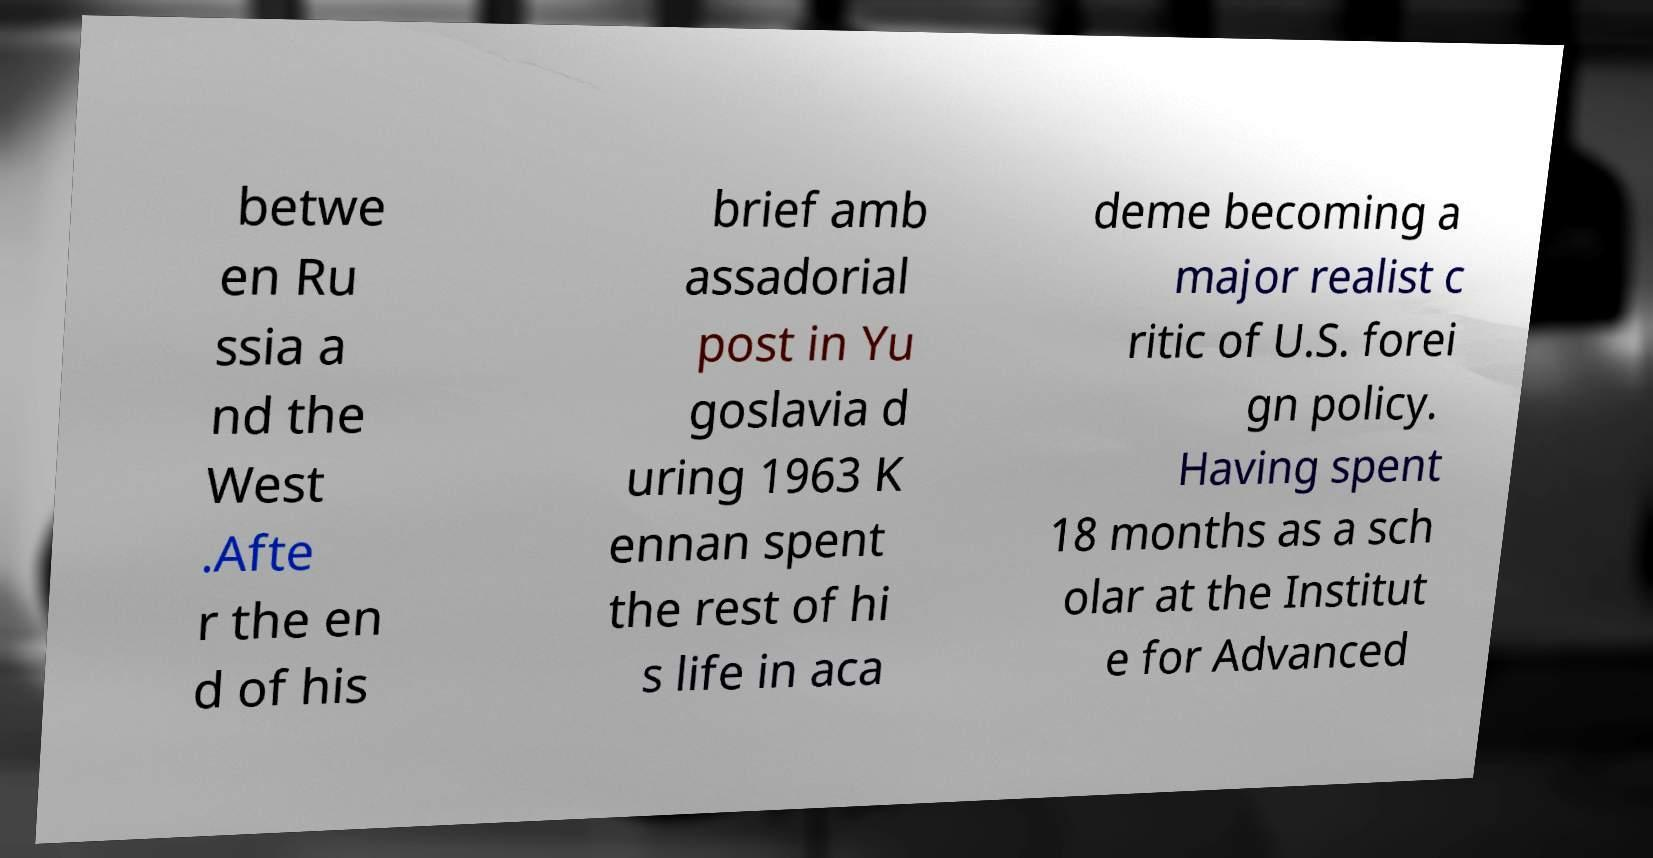Could you extract and type out the text from this image? betwe en Ru ssia a nd the West .Afte r the en d of his brief amb assadorial post in Yu goslavia d uring 1963 K ennan spent the rest of hi s life in aca deme becoming a major realist c ritic of U.S. forei gn policy. Having spent 18 months as a sch olar at the Institut e for Advanced 